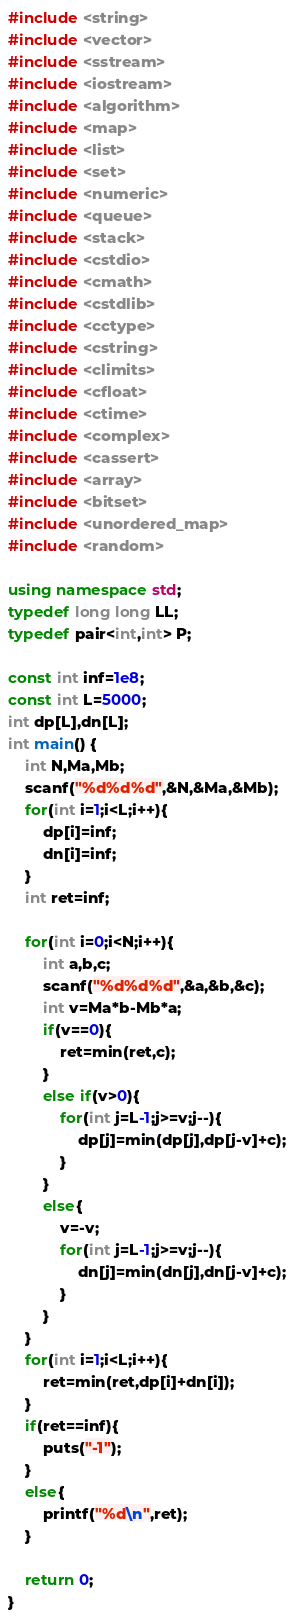Convert code to text. <code><loc_0><loc_0><loc_500><loc_500><_C++_>#include <string>
#include <vector>
#include <sstream>
#include <iostream>
#include <algorithm>
#include <map>
#include <list>
#include <set>
#include <numeric>
#include <queue>
#include <stack>
#include <cstdio>
#include <cmath>
#include <cstdlib>
#include <cctype>
#include <cstring>
#include <climits>
#include <cfloat>
#include <ctime>
#include <complex>
#include <cassert>
#include <array>
#include <bitset> 
#include <unordered_map>
#include <random>

using namespace std;
typedef long long LL;
typedef pair<int,int> P;

const int inf=1e8;
const int L=5000;
int dp[L],dn[L];
int main() {
	int N,Ma,Mb;
	scanf("%d%d%d",&N,&Ma,&Mb);
	for(int i=1;i<L;i++){
		dp[i]=inf;
		dn[i]=inf;
	}
	int ret=inf;

	for(int i=0;i<N;i++){
		int a,b,c;
		scanf("%d%d%d",&a,&b,&c);
		int v=Ma*b-Mb*a;
		if(v==0){
			ret=min(ret,c);
		}
		else if(v>0){
			for(int j=L-1;j>=v;j--){
				dp[j]=min(dp[j],dp[j-v]+c);
			}
		}
		else{
			v=-v;
			for(int j=L-1;j>=v;j--){
				dn[j]=min(dn[j],dn[j-v]+c);
			}
		}
	}
	for(int i=1;i<L;i++){
		ret=min(ret,dp[i]+dn[i]);
	}
	if(ret==inf){
		puts("-1");
	}
	else{
		printf("%d\n",ret);
	}

	return 0;
}

</code> 